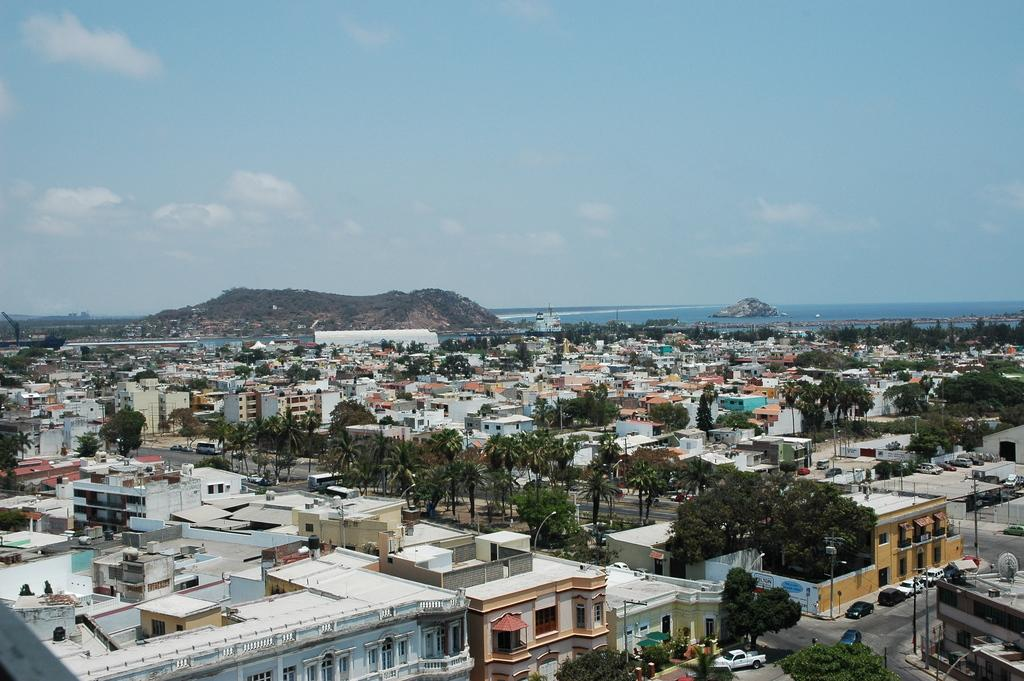What type of structures can be seen in the image? There are buildings in the image. What natural elements are present in the image? There are trees in the image. What man-made elements are present in the image? There are roads and cars in the image. What can be seen in the background of the image? There is a sea, a mountain, and the sky visible in the background of the image. How many chairs are visible in the image? There are no chairs present in the image. What type of throat condition can be seen in the image? There is no throat condition present in the image; it features buildings, trees, roads, cars, a sea, a mountain, and the sky. 